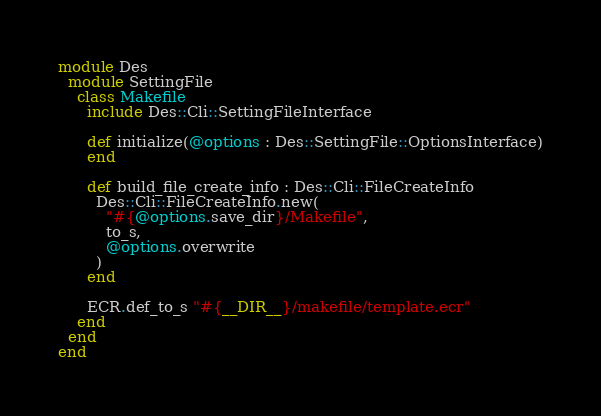<code> <loc_0><loc_0><loc_500><loc_500><_Crystal_>module Des
  module SettingFile
    class Makefile
      include Des::Cli::SettingFileInterface

      def initialize(@options : Des::SettingFile::OptionsInterface)
      end

      def build_file_create_info : Des::Cli::FileCreateInfo
        Des::Cli::FileCreateInfo.new(
          "#{@options.save_dir}/Makefile",
          to_s,
          @options.overwrite
        )
      end

      ECR.def_to_s "#{__DIR__}/makefile/template.ecr"
    end
  end
end
</code> 